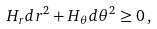<formula> <loc_0><loc_0><loc_500><loc_500>H _ { r } d r ^ { 2 } + H _ { \theta } d \theta ^ { 2 } \geq 0 \, ,</formula> 